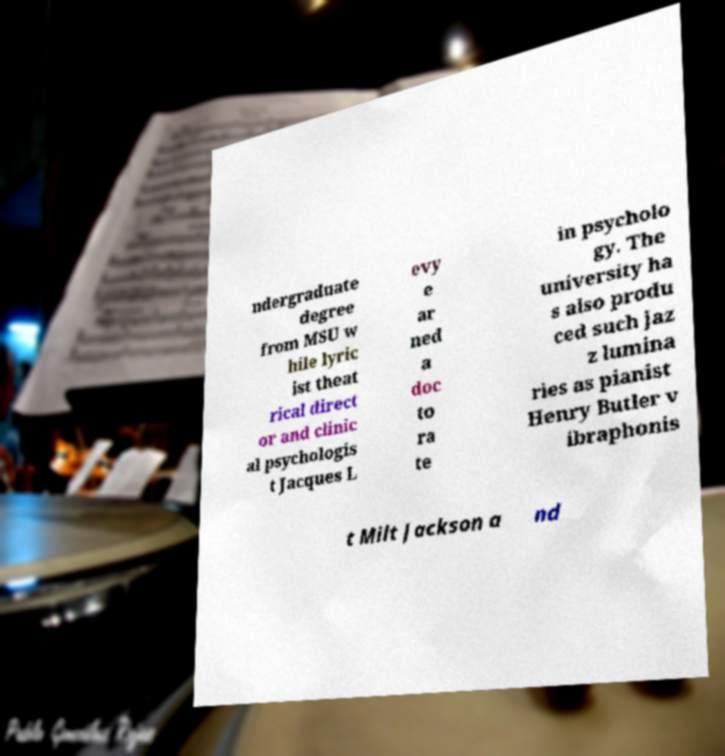Could you extract and type out the text from this image? ndergraduate degree from MSU w hile lyric ist theat rical direct or and clinic al psychologis t Jacques L evy e ar ned a doc to ra te in psycholo gy. The university ha s also produ ced such jaz z lumina ries as pianist Henry Butler v ibraphonis t Milt Jackson a nd 